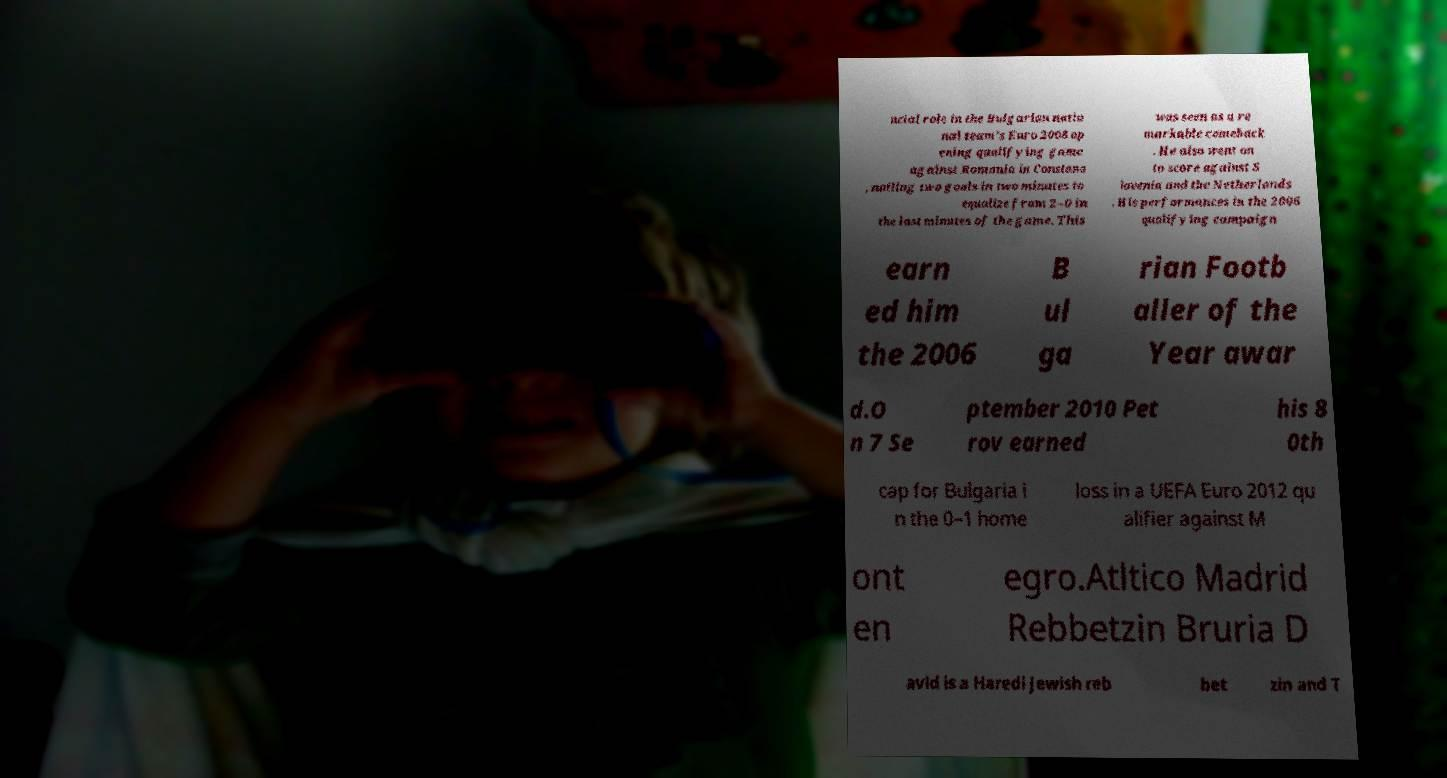Please identify and transcribe the text found in this image. ucial role in the Bulgarian natio nal team's Euro 2008 op ening qualifying game against Romania in Constana , nailing two goals in two minutes to equalize from 2–0 in the last minutes of the game. This was seen as a re markable comeback . He also went on to score against S lovenia and the Netherlands . His performances in the 2006 qualifying campaign earn ed him the 2006 B ul ga rian Footb aller of the Year awar d.O n 7 Se ptember 2010 Pet rov earned his 8 0th cap for Bulgaria i n the 0–1 home loss in a UEFA Euro 2012 qu alifier against M ont en egro.Atltico Madrid Rebbetzin Bruria D avid is a Haredi Jewish reb bet zin and T 